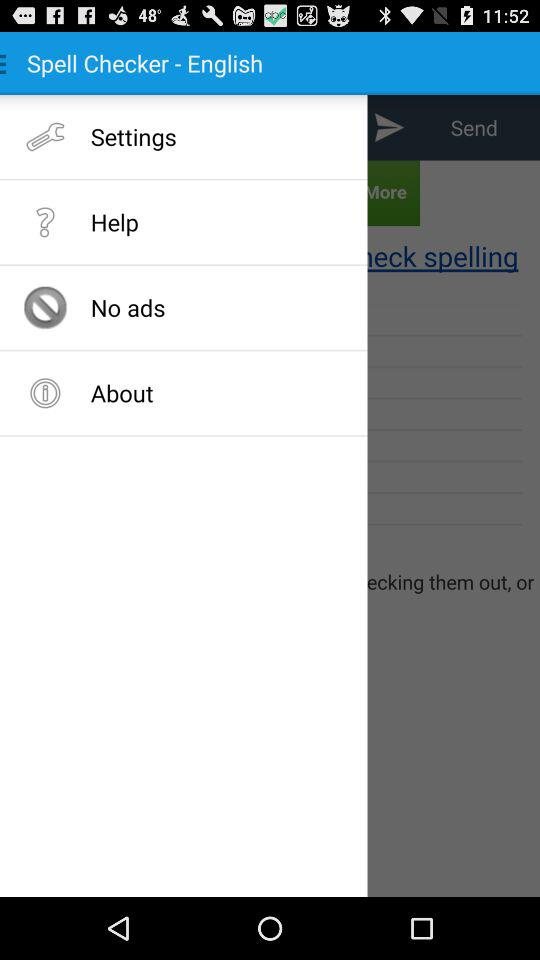What is the selected language in the "Spell Checker"? The selected language in the "Spell Checker" is English. 